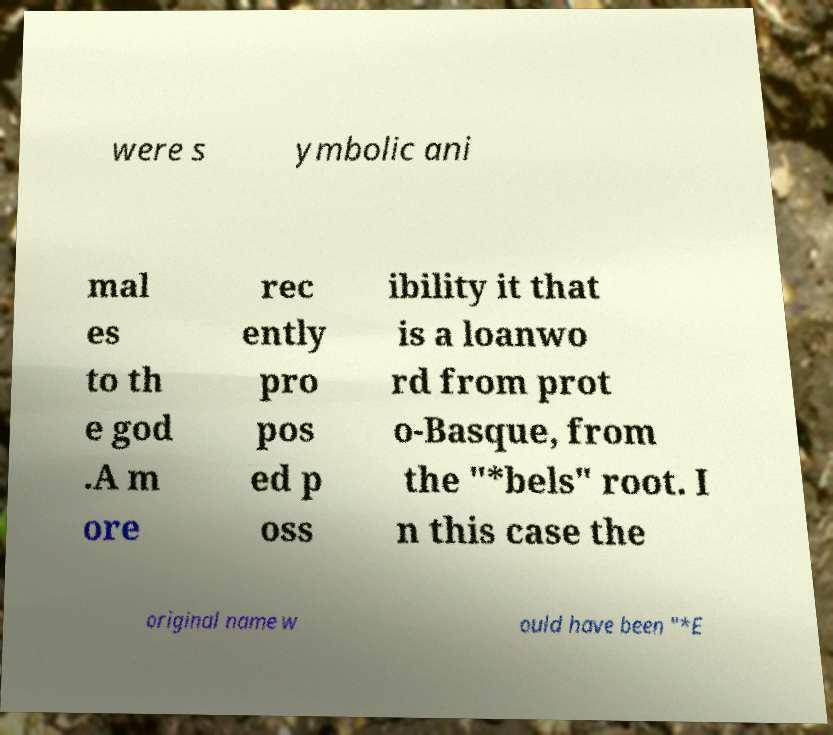I need the written content from this picture converted into text. Can you do that? were s ymbolic ani mal es to th e god .A m ore rec ently pro pos ed p oss ibility it that is a loanwo rd from prot o-Basque, from the "*bels" root. I n this case the original name w ould have been "*E 